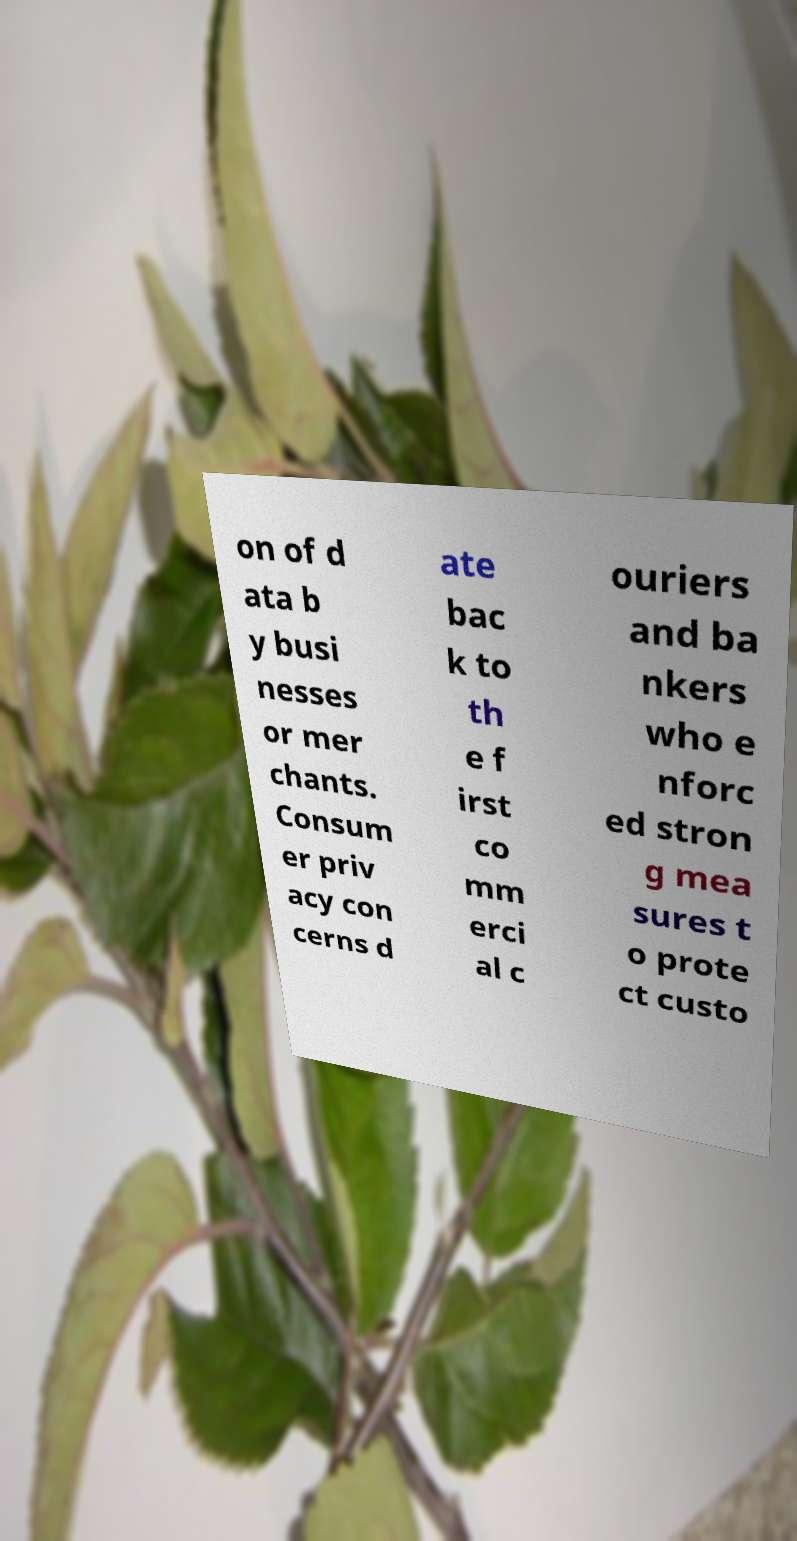Can you accurately transcribe the text from the provided image for me? on of d ata b y busi nesses or mer chants. Consum er priv acy con cerns d ate bac k to th e f irst co mm erci al c ouriers and ba nkers who e nforc ed stron g mea sures t o prote ct custo 